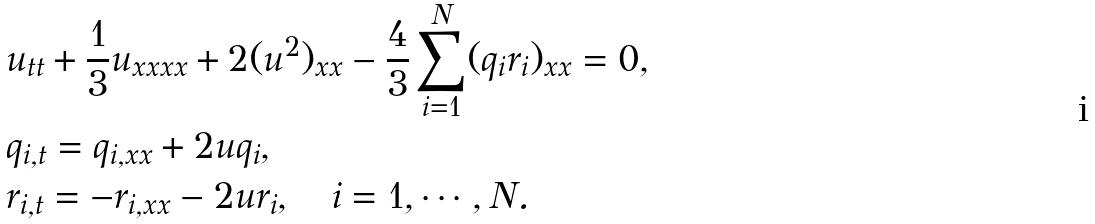Convert formula to latex. <formula><loc_0><loc_0><loc_500><loc_500>& u _ { t t } + \frac { 1 } { 3 } u _ { x x x x } + 2 ( u ^ { 2 } ) _ { x x } - \frac { 4 } { 3 } \sum _ { i = 1 } ^ { N } ( q _ { i } r _ { i } ) _ { x x } = 0 , \\ & q _ { i , t } = q _ { i , x x } + 2 u q _ { i } , \\ & r _ { i , t } = - r _ { i , x x } - 2 u r _ { i } , \quad i = 1 , \cdots , N .</formula> 